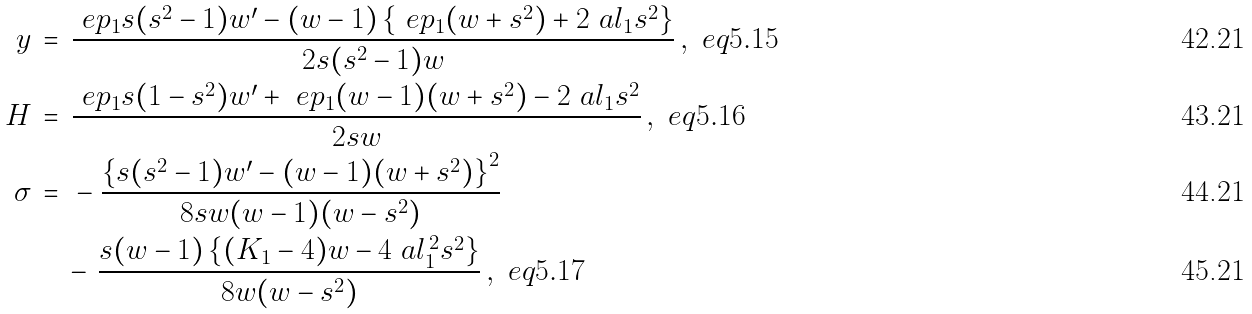Convert formula to latex. <formula><loc_0><loc_0><loc_500><loc_500>y & \, = \, \frac { \ e p _ { 1 } s ( s ^ { 2 } - 1 ) w ^ { \prime } - ( w - 1 ) \left \{ \ e p _ { 1 } ( w + s ^ { 2 } ) + 2 \ a l _ { 1 } s ^ { 2 } \right \} } { 2 s ( s ^ { 2 } - 1 ) w } \, , \ e q { 5 . 1 5 } \\ H & \, = \, \frac { \ e p _ { 1 } s ( 1 - s ^ { 2 } ) w ^ { \prime } + \ e p _ { 1 } ( w - 1 ) ( w + s ^ { 2 } ) - 2 \ a l _ { 1 } s ^ { 2 } } { 2 s w } \, , \ e q { 5 . 1 6 } \\ \sigma & \, = \, \null - \frac { \left \{ s ( s ^ { 2 } - 1 ) w ^ { \prime } - ( w - 1 ) ( w + s ^ { 2 } ) \right \} ^ { 2 } } { 8 s w ( w - 1 ) ( w - s ^ { 2 } ) } \\ & \quad \null \, - \, \frac { s ( w - 1 ) \left \{ ( K _ { 1 } - 4 ) w - 4 \ a l _ { 1 } ^ { \, 2 } s ^ { 2 } \right \} } { 8 w ( w - s ^ { 2 } ) } \, , \ e q { 5 . 1 7 }</formula> 